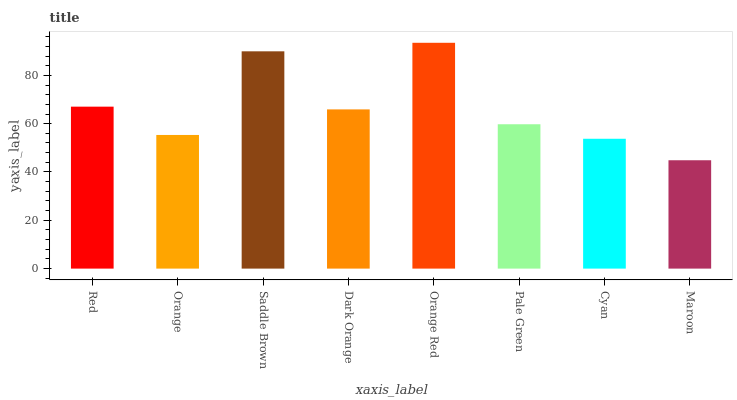Is Maroon the minimum?
Answer yes or no. Yes. Is Orange Red the maximum?
Answer yes or no. Yes. Is Orange the minimum?
Answer yes or no. No. Is Orange the maximum?
Answer yes or no. No. Is Red greater than Orange?
Answer yes or no. Yes. Is Orange less than Red?
Answer yes or no. Yes. Is Orange greater than Red?
Answer yes or no. No. Is Red less than Orange?
Answer yes or no. No. Is Dark Orange the high median?
Answer yes or no. Yes. Is Pale Green the low median?
Answer yes or no. Yes. Is Pale Green the high median?
Answer yes or no. No. Is Red the low median?
Answer yes or no. No. 